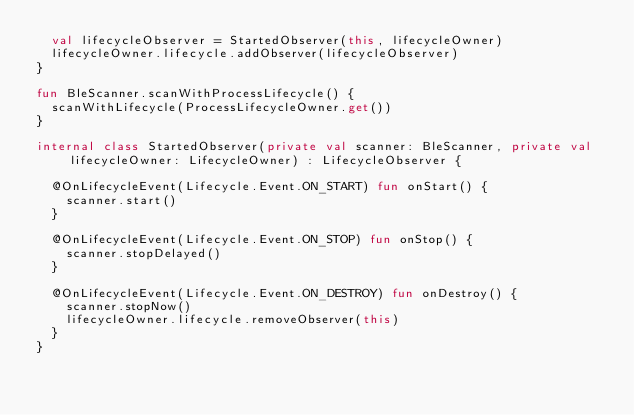Convert code to text. <code><loc_0><loc_0><loc_500><loc_500><_Kotlin_>	val lifecycleObserver = StartedObserver(this, lifecycleOwner)
	lifecycleOwner.lifecycle.addObserver(lifecycleObserver)
}

fun BleScanner.scanWithProcessLifecycle() {
	scanWithLifecycle(ProcessLifecycleOwner.get())
}

internal class StartedObserver(private val scanner: BleScanner, private val lifecycleOwner: LifecycleOwner) : LifecycleObserver {

	@OnLifecycleEvent(Lifecycle.Event.ON_START) fun onStart() {
		scanner.start()
	}

	@OnLifecycleEvent(Lifecycle.Event.ON_STOP) fun onStop() {
		scanner.stopDelayed()
	}

	@OnLifecycleEvent(Lifecycle.Event.ON_DESTROY) fun onDestroy() {
		scanner.stopNow()
		lifecycleOwner.lifecycle.removeObserver(this)
	}
}</code> 